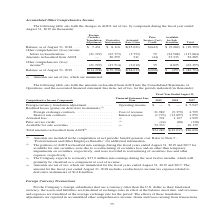From Jabil Circuit's financial document, Which periods does the table include? The document contains multiple relevant values: 2019, 2018, 2017. From the document: "Financial Statement Line Item 2019 2018 2017 component during the fiscal year ended August 31, 2019 (in thousands): Balance as of August 31, 2018 . $ ..." Also, What were the Foreign exchange contracts in 2019? According to the financial document, 21,982 (in thousands). The relevant text states: "(3) Foreign exchange contracts . Cost of revenue 21,982 (9,379) 4,799 Interest rate contracts . Interest expense (1,723) (13,697) 3,950 Actuarial loss . (1..." Also, What were the Interest rate contracts in 2018? According to the financial document, (13,697) (in thousands). The relevant text states: "Interest rate contracts . Interest expense (1,723) (13,697) 3,950 Actuarial loss . (1) 741 1,127 1,929 Prior service credit . (1) (44) (88) (138) Available for..." Also, can you calculate: What was the change in the Foreign exchange contracts between 2017 and 2019? Based on the calculation: 21,982-4,799, the result is 17183 (in thousands). This is based on the information: "change contracts . Cost of revenue 21,982 (9,379) 4,799 Interest rate contracts . Interest expense (1,723) (13,697) 3,950 Actuarial loss . (1) 741 1,127 1, (3) Foreign exchange contracts . Cost of rev..." The key data points involved are: 21,982, 4,799. Also, can you calculate: What was the change in the Interest rate contracts between 2018 and 2019? Based on the calculation: -1,723-(-13,697), the result is 11974 (in thousands). This is based on the information: "4,799 Interest rate contracts . Interest expense (1,723) (13,697) 3,950 Actuarial loss . (1) 741 1,127 1,929 Prior service credit . (1) (44) (88) (138) Ava terest rate contracts . Interest expense (1,..." The key data points involved are: 1,723, 13,697. Also, can you calculate: What was the percentage change in the Total amounts reclassified from AOCI between 2018 and 2019? To answer this question, I need to perform calculations using the financial data. The calculation is: ($54,289-(-$22,037))/-$22,037, which equals -346.35 (percentage). This is based on the information: "al amounts reclassified from AOCI (4) . $54,289 $(22,037) $26,626 reclassified from AOCI . — 20,259 741 (44) 33,333 54,289..." The key data points involved are: 22,037, 54,289. 